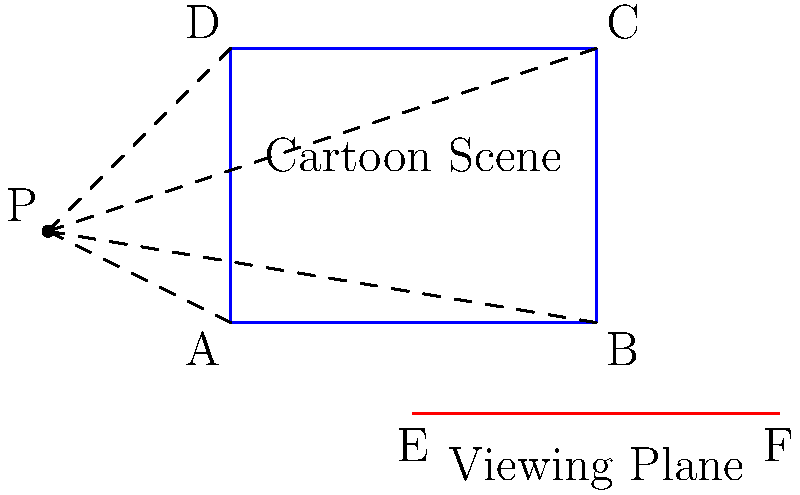In a 2D animation setup, a rectangular cartoon scene $ABCD$ is projected onto a viewing plane $EF$ from a projection point $P$. Given that $AB = 4$ units, $AD = 3$ units, $AE = 2$ units, $EF = 4$ units, and $P$ is located at $(-2,1)$, calculate the height of the projected image on the viewing plane. To solve this problem, we'll use the principles of perspective projection and similar triangles. Let's approach this step-by-step:

1) First, we need to find the projection of points A and D onto the viewing plane. Let's call these points A' and D' respectively.

2) To find A', we can use the equation of the line PA:
   $y - 1 = m(x + 2)$, where $m = \frac{0-1}{0-(-2)} = \frac{1}{2}$
   
   The equation of PA is thus: $y - 1 = \frac{1}{2}(x + 2)$ or $y = \frac{1}{2}x + 2$

3) The viewing plane EF has the equation $y = -1$

4) To find A', we solve these equations simultaneously:
   $\frac{1}{2}x + 2 = -1$
   $x = -6$
   So, A' is at $(-6, -1)$

5) Similarly, for D', we use the line PD:
   $y - 1 = m(x + 2)$, where $m = \frac{3-1}{0-(-2)} = -1$
   
   The equation of PD is: $y - 1 = -(x + 2)$ or $y = -x - 1$

6) Solving with $y = -1$:
   $-1 = -x - 1$
   $x = 0$
   So, D' is at $(0, -1)$

7) The height of the projected image is the distance between A' and D':
   $|A'D'| = |-6 - 0| = 6$ units

Therefore, the height of the projected image on the viewing plane is 6 units.
Answer: 6 units 